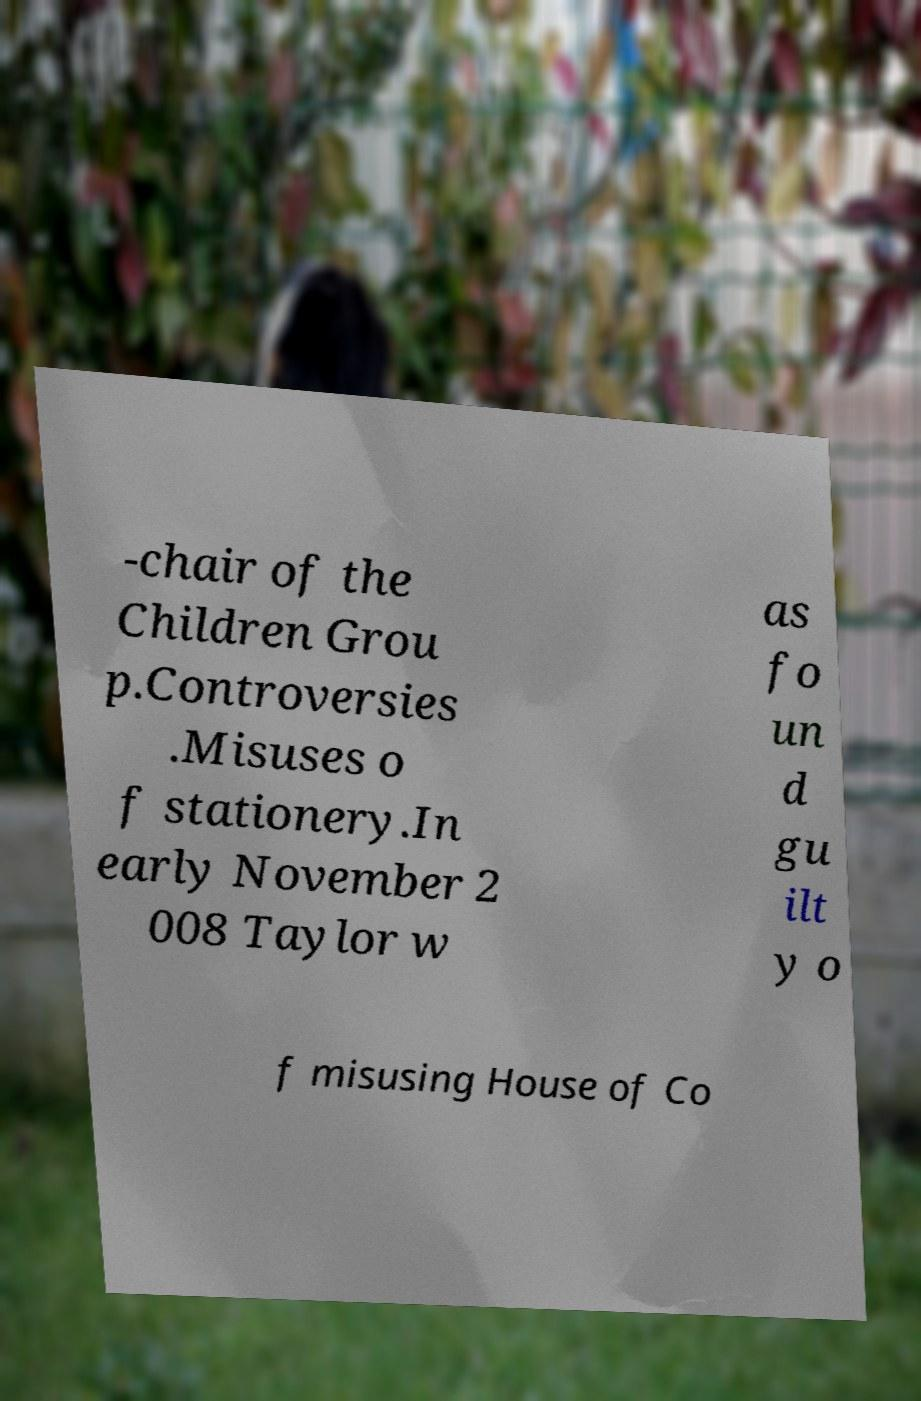What messages or text are displayed in this image? I need them in a readable, typed format. -chair of the Children Grou p.Controversies .Misuses o f stationery.In early November 2 008 Taylor w as fo un d gu ilt y o f misusing House of Co 